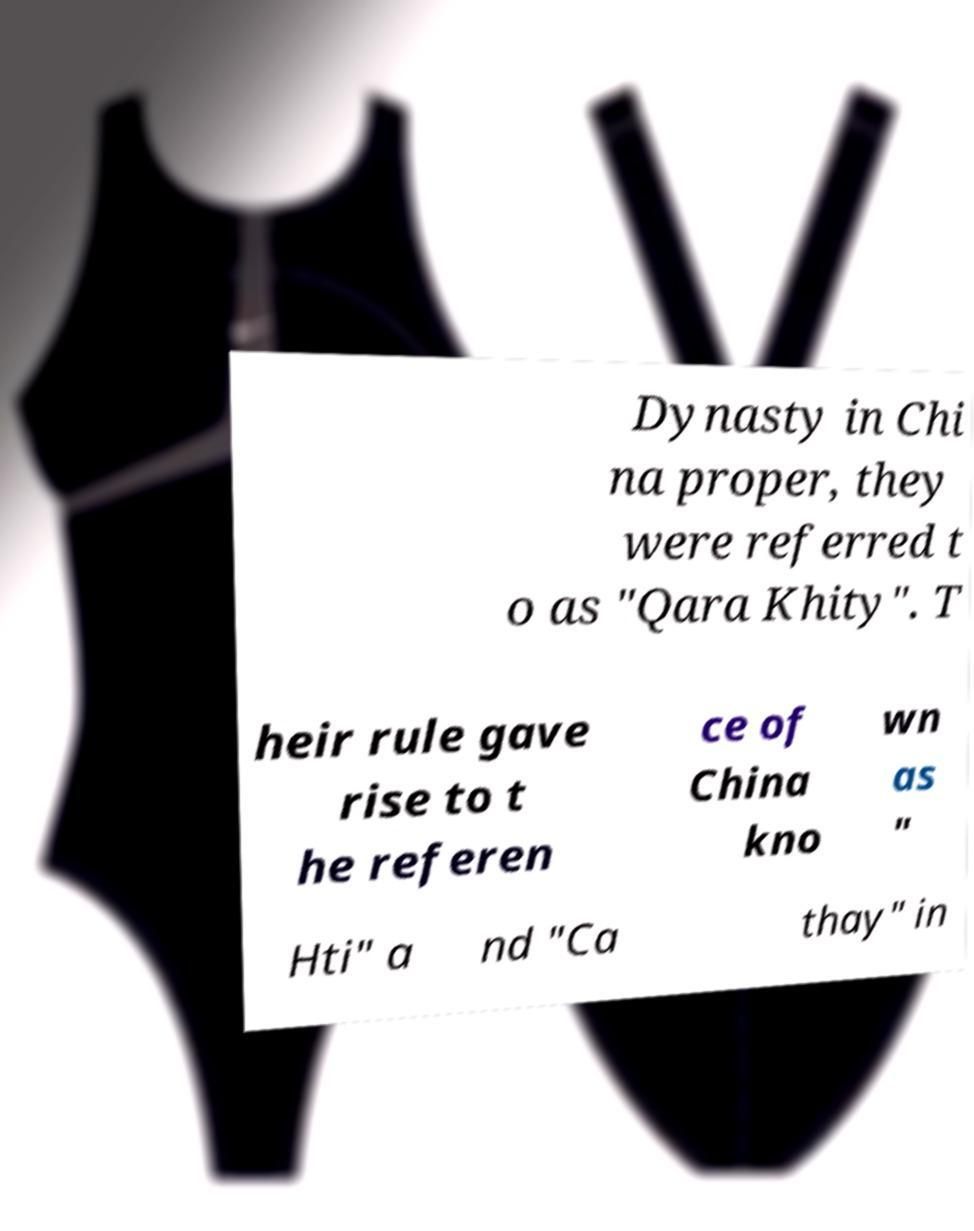Please read and relay the text visible in this image. What does it say? Dynasty in Chi na proper, they were referred t o as "Qara Khity". T heir rule gave rise to t he referen ce of China kno wn as " Hti" a nd "Ca thay" in 